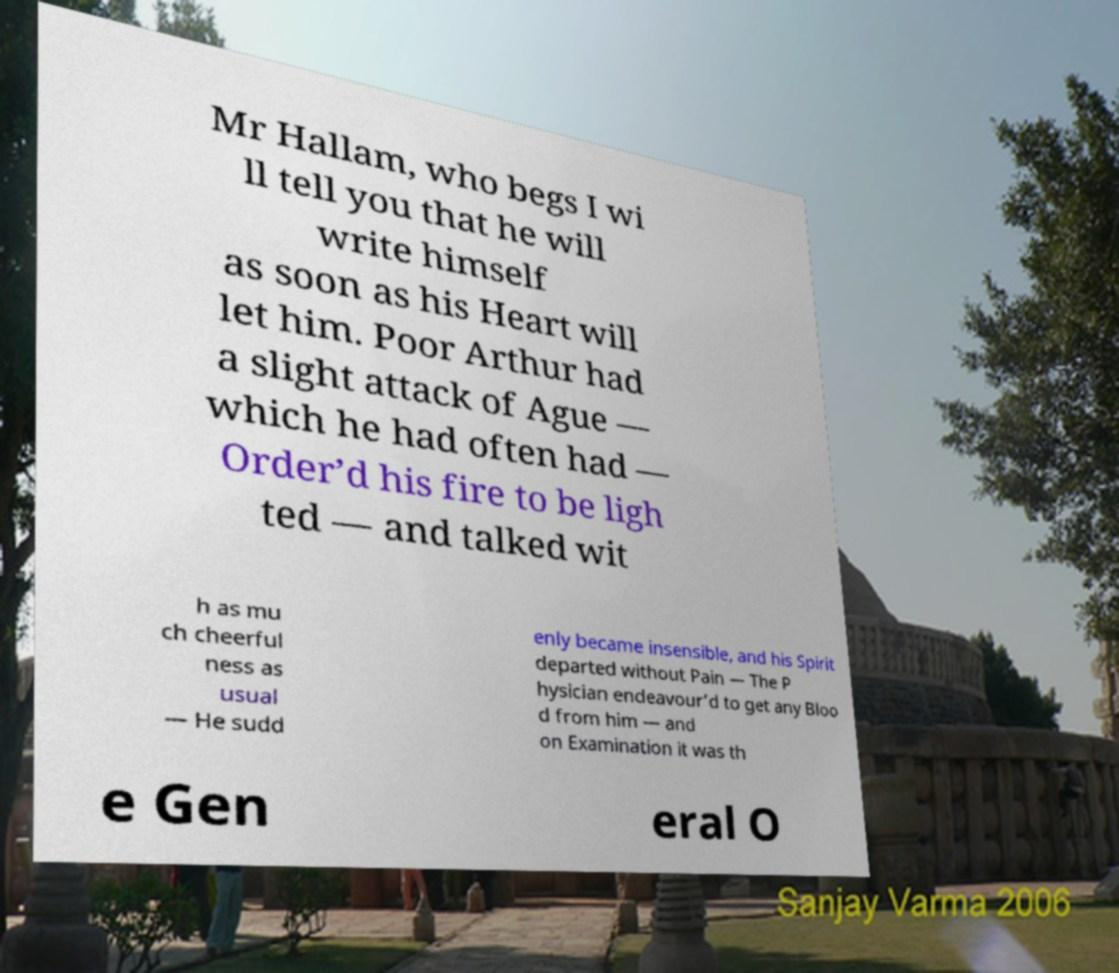Can you read and provide the text displayed in the image?This photo seems to have some interesting text. Can you extract and type it out for me? Mr Hallam, who begs I wi ll tell you that he will write himself as soon as his Heart will let him. Poor Arthur had a slight attack of Ague — which he had often had — Order’d his fire to be ligh ted — and talked wit h as mu ch cheerful ness as usual — He sudd enly became insensible, and his Spirit departed without Pain — The P hysician endeavour’d to get any Bloo d from him — and on Examination it was th e Gen eral O 